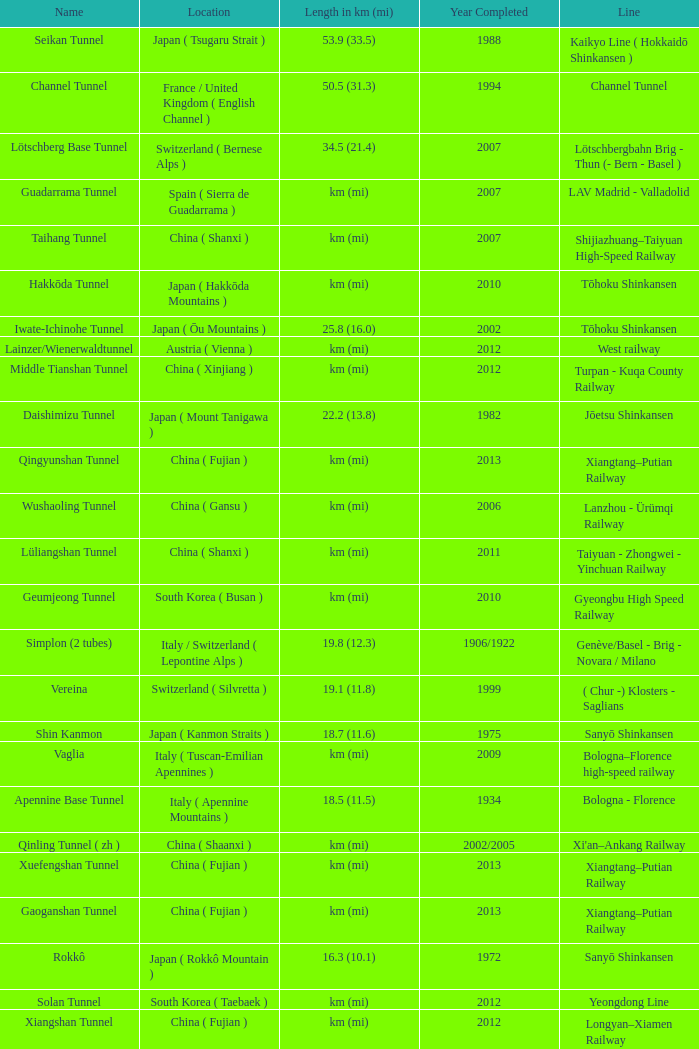In which year was the gardermobanen line finished? 1999.0. 